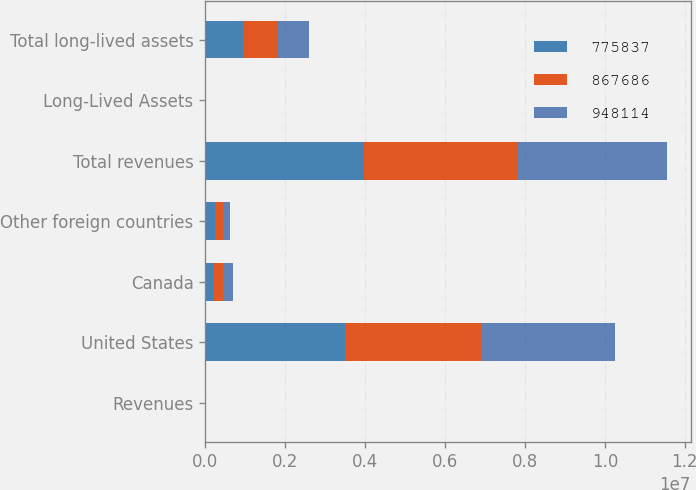Convert chart to OTSL. <chart><loc_0><loc_0><loc_500><loc_500><stacked_bar_chart><ecel><fcel>Revenues<fcel>United States<fcel>Canada<fcel>Other foreign countries<fcel>Total revenues<fcel>Long-Lived Assets<fcel>Total long-lived assets<nl><fcel>775837<fcel>2016<fcel>3.49346e+06<fcel>228685<fcel>239892<fcel>3.96204e+06<fcel>2016<fcel>948114<nl><fcel>867686<fcel>2015<fcel>3.44114e+06<fcel>223270<fcel>204776<fcel>3.86919e+06<fcel>2015<fcel>867686<nl><fcel>948114<fcel>2014<fcel>3.30823e+06<fcel>238590<fcel>186691<fcel>3.73351e+06<fcel>2014<fcel>775837<nl></chart> 